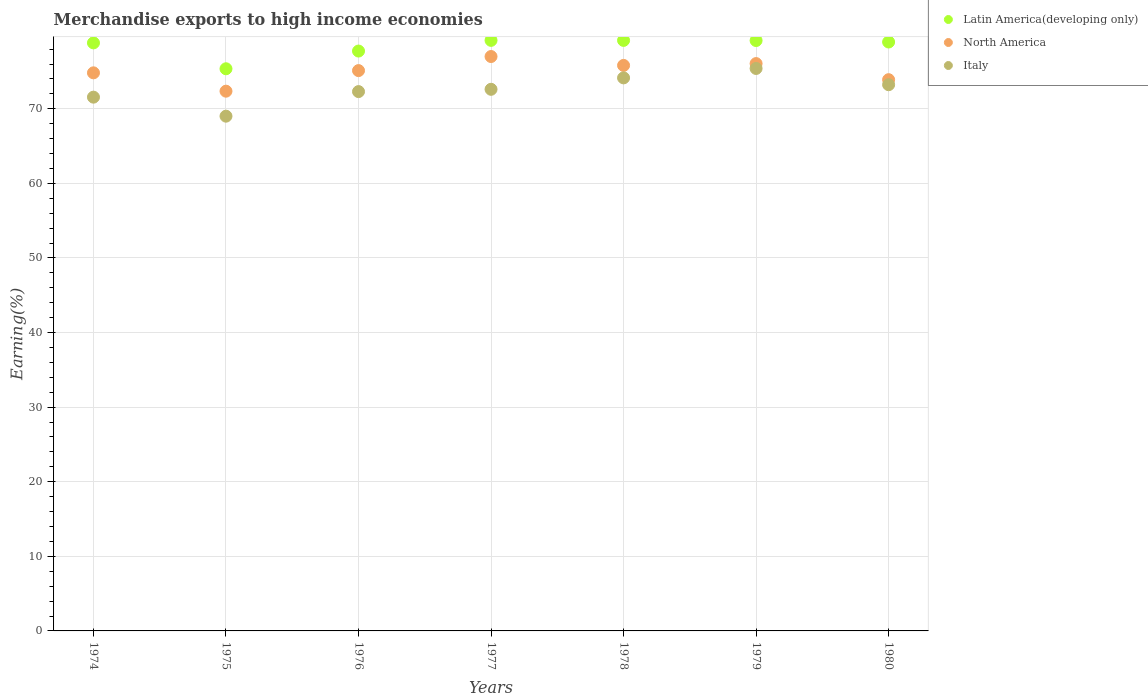Is the number of dotlines equal to the number of legend labels?
Your answer should be compact. Yes. What is the percentage of amount earned from merchandise exports in North America in 1975?
Provide a succinct answer. 72.36. Across all years, what is the maximum percentage of amount earned from merchandise exports in Latin America(developing only)?
Keep it short and to the point. 79.17. Across all years, what is the minimum percentage of amount earned from merchandise exports in Italy?
Make the answer very short. 69.01. In which year was the percentage of amount earned from merchandise exports in Italy maximum?
Keep it short and to the point. 1979. In which year was the percentage of amount earned from merchandise exports in Latin America(developing only) minimum?
Offer a terse response. 1975. What is the total percentage of amount earned from merchandise exports in North America in the graph?
Your answer should be compact. 525.07. What is the difference between the percentage of amount earned from merchandise exports in Italy in 1974 and that in 1975?
Your answer should be very brief. 2.55. What is the difference between the percentage of amount earned from merchandise exports in Latin America(developing only) in 1979 and the percentage of amount earned from merchandise exports in Italy in 1976?
Your response must be concise. 6.85. What is the average percentage of amount earned from merchandise exports in North America per year?
Provide a succinct answer. 75.01. In the year 1974, what is the difference between the percentage of amount earned from merchandise exports in North America and percentage of amount earned from merchandise exports in Latin America(developing only)?
Ensure brevity in your answer.  -4.02. What is the ratio of the percentage of amount earned from merchandise exports in Latin America(developing only) in 1979 to that in 1980?
Make the answer very short. 1. Is the percentage of amount earned from merchandise exports in Latin America(developing only) in 1974 less than that in 1979?
Your answer should be very brief. Yes. Is the difference between the percentage of amount earned from merchandise exports in North America in 1976 and 1978 greater than the difference between the percentage of amount earned from merchandise exports in Latin America(developing only) in 1976 and 1978?
Your answer should be compact. Yes. What is the difference between the highest and the second highest percentage of amount earned from merchandise exports in Latin America(developing only)?
Provide a succinct answer. 0. What is the difference between the highest and the lowest percentage of amount earned from merchandise exports in North America?
Your answer should be compact. 4.65. Does the percentage of amount earned from merchandise exports in Italy monotonically increase over the years?
Make the answer very short. No. Is the percentage of amount earned from merchandise exports in North America strictly greater than the percentage of amount earned from merchandise exports in Italy over the years?
Offer a very short reply. Yes. Does the graph contain any zero values?
Offer a terse response. No. Where does the legend appear in the graph?
Offer a terse response. Top right. How are the legend labels stacked?
Your answer should be very brief. Vertical. What is the title of the graph?
Your answer should be compact. Merchandise exports to high income economies. What is the label or title of the X-axis?
Your answer should be very brief. Years. What is the label or title of the Y-axis?
Provide a short and direct response. Earning(%). What is the Earning(%) of Latin America(developing only) in 1974?
Keep it short and to the point. 78.83. What is the Earning(%) in North America in 1974?
Offer a terse response. 74.82. What is the Earning(%) of Italy in 1974?
Keep it short and to the point. 71.56. What is the Earning(%) in Latin America(developing only) in 1975?
Offer a very short reply. 75.36. What is the Earning(%) in North America in 1975?
Keep it short and to the point. 72.36. What is the Earning(%) in Italy in 1975?
Offer a terse response. 69.01. What is the Earning(%) in Latin America(developing only) in 1976?
Keep it short and to the point. 77.74. What is the Earning(%) of North America in 1976?
Provide a succinct answer. 75.12. What is the Earning(%) of Italy in 1976?
Offer a terse response. 72.3. What is the Earning(%) of Latin America(developing only) in 1977?
Offer a very short reply. 79.17. What is the Earning(%) in North America in 1977?
Your response must be concise. 77. What is the Earning(%) of Italy in 1977?
Give a very brief answer. 72.61. What is the Earning(%) in Latin America(developing only) in 1978?
Your answer should be very brief. 79.17. What is the Earning(%) in North America in 1978?
Offer a very short reply. 75.81. What is the Earning(%) in Italy in 1978?
Provide a succinct answer. 74.14. What is the Earning(%) of Latin America(developing only) in 1979?
Your response must be concise. 79.15. What is the Earning(%) in North America in 1979?
Give a very brief answer. 76.06. What is the Earning(%) in Italy in 1979?
Make the answer very short. 75.4. What is the Earning(%) of Latin America(developing only) in 1980?
Your response must be concise. 78.95. What is the Earning(%) in North America in 1980?
Keep it short and to the point. 73.9. What is the Earning(%) in Italy in 1980?
Provide a short and direct response. 73.23. Across all years, what is the maximum Earning(%) of Latin America(developing only)?
Keep it short and to the point. 79.17. Across all years, what is the maximum Earning(%) of North America?
Your response must be concise. 77. Across all years, what is the maximum Earning(%) in Italy?
Offer a terse response. 75.4. Across all years, what is the minimum Earning(%) of Latin America(developing only)?
Provide a succinct answer. 75.36. Across all years, what is the minimum Earning(%) of North America?
Ensure brevity in your answer.  72.36. Across all years, what is the minimum Earning(%) of Italy?
Keep it short and to the point. 69.01. What is the total Earning(%) in Latin America(developing only) in the graph?
Give a very brief answer. 548.37. What is the total Earning(%) in North America in the graph?
Your response must be concise. 525.07. What is the total Earning(%) in Italy in the graph?
Keep it short and to the point. 508.25. What is the difference between the Earning(%) in Latin America(developing only) in 1974 and that in 1975?
Give a very brief answer. 3.47. What is the difference between the Earning(%) in North America in 1974 and that in 1975?
Give a very brief answer. 2.46. What is the difference between the Earning(%) in Italy in 1974 and that in 1975?
Your answer should be compact. 2.55. What is the difference between the Earning(%) of Latin America(developing only) in 1974 and that in 1976?
Offer a terse response. 1.09. What is the difference between the Earning(%) in North America in 1974 and that in 1976?
Your answer should be very brief. -0.3. What is the difference between the Earning(%) of Italy in 1974 and that in 1976?
Your answer should be compact. -0.75. What is the difference between the Earning(%) of Latin America(developing only) in 1974 and that in 1977?
Your response must be concise. -0.34. What is the difference between the Earning(%) of North America in 1974 and that in 1977?
Provide a short and direct response. -2.19. What is the difference between the Earning(%) in Italy in 1974 and that in 1977?
Your response must be concise. -1.05. What is the difference between the Earning(%) in Latin America(developing only) in 1974 and that in 1978?
Your answer should be compact. -0.33. What is the difference between the Earning(%) in North America in 1974 and that in 1978?
Provide a short and direct response. -1. What is the difference between the Earning(%) in Italy in 1974 and that in 1978?
Provide a short and direct response. -2.58. What is the difference between the Earning(%) of Latin America(developing only) in 1974 and that in 1979?
Provide a succinct answer. -0.32. What is the difference between the Earning(%) of North America in 1974 and that in 1979?
Your response must be concise. -1.24. What is the difference between the Earning(%) of Italy in 1974 and that in 1979?
Your response must be concise. -3.85. What is the difference between the Earning(%) of Latin America(developing only) in 1974 and that in 1980?
Offer a terse response. -0.12. What is the difference between the Earning(%) of North America in 1974 and that in 1980?
Your response must be concise. 0.92. What is the difference between the Earning(%) of Italy in 1974 and that in 1980?
Ensure brevity in your answer.  -1.67. What is the difference between the Earning(%) in Latin America(developing only) in 1975 and that in 1976?
Give a very brief answer. -2.37. What is the difference between the Earning(%) of North America in 1975 and that in 1976?
Your response must be concise. -2.76. What is the difference between the Earning(%) of Italy in 1975 and that in 1976?
Your answer should be very brief. -3.29. What is the difference between the Earning(%) in Latin America(developing only) in 1975 and that in 1977?
Offer a terse response. -3.81. What is the difference between the Earning(%) of North America in 1975 and that in 1977?
Give a very brief answer. -4.65. What is the difference between the Earning(%) in Italy in 1975 and that in 1977?
Ensure brevity in your answer.  -3.6. What is the difference between the Earning(%) of Latin America(developing only) in 1975 and that in 1978?
Keep it short and to the point. -3.8. What is the difference between the Earning(%) in North America in 1975 and that in 1978?
Give a very brief answer. -3.45. What is the difference between the Earning(%) of Italy in 1975 and that in 1978?
Keep it short and to the point. -5.13. What is the difference between the Earning(%) of Latin America(developing only) in 1975 and that in 1979?
Ensure brevity in your answer.  -3.79. What is the difference between the Earning(%) of North America in 1975 and that in 1979?
Provide a succinct answer. -3.7. What is the difference between the Earning(%) of Italy in 1975 and that in 1979?
Your answer should be compact. -6.4. What is the difference between the Earning(%) in Latin America(developing only) in 1975 and that in 1980?
Provide a short and direct response. -3.59. What is the difference between the Earning(%) in North America in 1975 and that in 1980?
Give a very brief answer. -1.54. What is the difference between the Earning(%) in Italy in 1975 and that in 1980?
Make the answer very short. -4.22. What is the difference between the Earning(%) in Latin America(developing only) in 1976 and that in 1977?
Your answer should be compact. -1.43. What is the difference between the Earning(%) in North America in 1976 and that in 1977?
Give a very brief answer. -1.89. What is the difference between the Earning(%) of Italy in 1976 and that in 1977?
Ensure brevity in your answer.  -0.31. What is the difference between the Earning(%) in Latin America(developing only) in 1976 and that in 1978?
Offer a very short reply. -1.43. What is the difference between the Earning(%) of North America in 1976 and that in 1978?
Keep it short and to the point. -0.69. What is the difference between the Earning(%) of Italy in 1976 and that in 1978?
Offer a very short reply. -1.84. What is the difference between the Earning(%) in Latin America(developing only) in 1976 and that in 1979?
Give a very brief answer. -1.41. What is the difference between the Earning(%) of North America in 1976 and that in 1979?
Keep it short and to the point. -0.94. What is the difference between the Earning(%) in Italy in 1976 and that in 1979?
Provide a succinct answer. -3.1. What is the difference between the Earning(%) in Latin America(developing only) in 1976 and that in 1980?
Ensure brevity in your answer.  -1.21. What is the difference between the Earning(%) of North America in 1976 and that in 1980?
Your answer should be very brief. 1.22. What is the difference between the Earning(%) in Italy in 1976 and that in 1980?
Offer a terse response. -0.92. What is the difference between the Earning(%) of Latin America(developing only) in 1977 and that in 1978?
Give a very brief answer. 0. What is the difference between the Earning(%) in North America in 1977 and that in 1978?
Your answer should be compact. 1.19. What is the difference between the Earning(%) of Italy in 1977 and that in 1978?
Your response must be concise. -1.53. What is the difference between the Earning(%) of Latin America(developing only) in 1977 and that in 1979?
Provide a succinct answer. 0.02. What is the difference between the Earning(%) in North America in 1977 and that in 1979?
Your answer should be very brief. 0.95. What is the difference between the Earning(%) in Italy in 1977 and that in 1979?
Your answer should be very brief. -2.79. What is the difference between the Earning(%) in Latin America(developing only) in 1977 and that in 1980?
Keep it short and to the point. 0.22. What is the difference between the Earning(%) of North America in 1977 and that in 1980?
Offer a terse response. 3.1. What is the difference between the Earning(%) in Italy in 1977 and that in 1980?
Make the answer very short. -0.62. What is the difference between the Earning(%) in Latin America(developing only) in 1978 and that in 1979?
Offer a terse response. 0.02. What is the difference between the Earning(%) of North America in 1978 and that in 1979?
Your answer should be compact. -0.25. What is the difference between the Earning(%) in Italy in 1978 and that in 1979?
Give a very brief answer. -1.26. What is the difference between the Earning(%) in Latin America(developing only) in 1978 and that in 1980?
Offer a terse response. 0.22. What is the difference between the Earning(%) of North America in 1978 and that in 1980?
Provide a succinct answer. 1.91. What is the difference between the Earning(%) of Italy in 1978 and that in 1980?
Your answer should be compact. 0.92. What is the difference between the Earning(%) of Latin America(developing only) in 1979 and that in 1980?
Your answer should be very brief. 0.2. What is the difference between the Earning(%) in North America in 1979 and that in 1980?
Your answer should be compact. 2.16. What is the difference between the Earning(%) in Italy in 1979 and that in 1980?
Your answer should be very brief. 2.18. What is the difference between the Earning(%) in Latin America(developing only) in 1974 and the Earning(%) in North America in 1975?
Give a very brief answer. 6.47. What is the difference between the Earning(%) of Latin America(developing only) in 1974 and the Earning(%) of Italy in 1975?
Offer a very short reply. 9.82. What is the difference between the Earning(%) of North America in 1974 and the Earning(%) of Italy in 1975?
Make the answer very short. 5.81. What is the difference between the Earning(%) of Latin America(developing only) in 1974 and the Earning(%) of North America in 1976?
Provide a short and direct response. 3.71. What is the difference between the Earning(%) of Latin America(developing only) in 1974 and the Earning(%) of Italy in 1976?
Provide a short and direct response. 6.53. What is the difference between the Earning(%) in North America in 1974 and the Earning(%) in Italy in 1976?
Give a very brief answer. 2.51. What is the difference between the Earning(%) in Latin America(developing only) in 1974 and the Earning(%) in North America in 1977?
Your answer should be very brief. 1.83. What is the difference between the Earning(%) in Latin America(developing only) in 1974 and the Earning(%) in Italy in 1977?
Make the answer very short. 6.22. What is the difference between the Earning(%) of North America in 1974 and the Earning(%) of Italy in 1977?
Your answer should be compact. 2.21. What is the difference between the Earning(%) in Latin America(developing only) in 1974 and the Earning(%) in North America in 1978?
Your answer should be very brief. 3.02. What is the difference between the Earning(%) of Latin America(developing only) in 1974 and the Earning(%) of Italy in 1978?
Your answer should be compact. 4.69. What is the difference between the Earning(%) of North America in 1974 and the Earning(%) of Italy in 1978?
Offer a terse response. 0.68. What is the difference between the Earning(%) of Latin America(developing only) in 1974 and the Earning(%) of North America in 1979?
Your answer should be compact. 2.77. What is the difference between the Earning(%) in Latin America(developing only) in 1974 and the Earning(%) in Italy in 1979?
Provide a succinct answer. 3.43. What is the difference between the Earning(%) of North America in 1974 and the Earning(%) of Italy in 1979?
Provide a succinct answer. -0.59. What is the difference between the Earning(%) of Latin America(developing only) in 1974 and the Earning(%) of North America in 1980?
Offer a very short reply. 4.93. What is the difference between the Earning(%) of Latin America(developing only) in 1974 and the Earning(%) of Italy in 1980?
Ensure brevity in your answer.  5.61. What is the difference between the Earning(%) of North America in 1974 and the Earning(%) of Italy in 1980?
Your response must be concise. 1.59. What is the difference between the Earning(%) in Latin America(developing only) in 1975 and the Earning(%) in North America in 1976?
Your answer should be very brief. 0.25. What is the difference between the Earning(%) of Latin America(developing only) in 1975 and the Earning(%) of Italy in 1976?
Give a very brief answer. 3.06. What is the difference between the Earning(%) of North America in 1975 and the Earning(%) of Italy in 1976?
Provide a short and direct response. 0.06. What is the difference between the Earning(%) in Latin America(developing only) in 1975 and the Earning(%) in North America in 1977?
Ensure brevity in your answer.  -1.64. What is the difference between the Earning(%) in Latin America(developing only) in 1975 and the Earning(%) in Italy in 1977?
Offer a very short reply. 2.75. What is the difference between the Earning(%) in North America in 1975 and the Earning(%) in Italy in 1977?
Your answer should be very brief. -0.25. What is the difference between the Earning(%) of Latin America(developing only) in 1975 and the Earning(%) of North America in 1978?
Offer a very short reply. -0.45. What is the difference between the Earning(%) of Latin America(developing only) in 1975 and the Earning(%) of Italy in 1978?
Keep it short and to the point. 1.22. What is the difference between the Earning(%) in North America in 1975 and the Earning(%) in Italy in 1978?
Ensure brevity in your answer.  -1.78. What is the difference between the Earning(%) of Latin America(developing only) in 1975 and the Earning(%) of North America in 1979?
Ensure brevity in your answer.  -0.7. What is the difference between the Earning(%) in Latin America(developing only) in 1975 and the Earning(%) in Italy in 1979?
Give a very brief answer. -0.04. What is the difference between the Earning(%) in North America in 1975 and the Earning(%) in Italy in 1979?
Give a very brief answer. -3.05. What is the difference between the Earning(%) of Latin America(developing only) in 1975 and the Earning(%) of North America in 1980?
Keep it short and to the point. 1.46. What is the difference between the Earning(%) in Latin America(developing only) in 1975 and the Earning(%) in Italy in 1980?
Your response must be concise. 2.14. What is the difference between the Earning(%) of North America in 1975 and the Earning(%) of Italy in 1980?
Give a very brief answer. -0.87. What is the difference between the Earning(%) in Latin America(developing only) in 1976 and the Earning(%) in North America in 1977?
Make the answer very short. 0.73. What is the difference between the Earning(%) in Latin America(developing only) in 1976 and the Earning(%) in Italy in 1977?
Provide a succinct answer. 5.13. What is the difference between the Earning(%) of North America in 1976 and the Earning(%) of Italy in 1977?
Offer a terse response. 2.51. What is the difference between the Earning(%) in Latin America(developing only) in 1976 and the Earning(%) in North America in 1978?
Make the answer very short. 1.93. What is the difference between the Earning(%) of Latin America(developing only) in 1976 and the Earning(%) of Italy in 1978?
Your answer should be compact. 3.6. What is the difference between the Earning(%) in North America in 1976 and the Earning(%) in Italy in 1978?
Keep it short and to the point. 0.98. What is the difference between the Earning(%) in Latin America(developing only) in 1976 and the Earning(%) in North America in 1979?
Give a very brief answer. 1.68. What is the difference between the Earning(%) in Latin America(developing only) in 1976 and the Earning(%) in Italy in 1979?
Keep it short and to the point. 2.33. What is the difference between the Earning(%) of North America in 1976 and the Earning(%) of Italy in 1979?
Provide a succinct answer. -0.29. What is the difference between the Earning(%) in Latin America(developing only) in 1976 and the Earning(%) in North America in 1980?
Offer a very short reply. 3.84. What is the difference between the Earning(%) of Latin America(developing only) in 1976 and the Earning(%) of Italy in 1980?
Your answer should be compact. 4.51. What is the difference between the Earning(%) of North America in 1976 and the Earning(%) of Italy in 1980?
Offer a terse response. 1.89. What is the difference between the Earning(%) in Latin America(developing only) in 1977 and the Earning(%) in North America in 1978?
Provide a succinct answer. 3.36. What is the difference between the Earning(%) in Latin America(developing only) in 1977 and the Earning(%) in Italy in 1978?
Your answer should be very brief. 5.03. What is the difference between the Earning(%) of North America in 1977 and the Earning(%) of Italy in 1978?
Keep it short and to the point. 2.86. What is the difference between the Earning(%) of Latin America(developing only) in 1977 and the Earning(%) of North America in 1979?
Your answer should be very brief. 3.11. What is the difference between the Earning(%) in Latin America(developing only) in 1977 and the Earning(%) in Italy in 1979?
Provide a succinct answer. 3.77. What is the difference between the Earning(%) of North America in 1977 and the Earning(%) of Italy in 1979?
Provide a succinct answer. 1.6. What is the difference between the Earning(%) of Latin America(developing only) in 1977 and the Earning(%) of North America in 1980?
Offer a terse response. 5.27. What is the difference between the Earning(%) in Latin America(developing only) in 1977 and the Earning(%) in Italy in 1980?
Make the answer very short. 5.95. What is the difference between the Earning(%) in North America in 1977 and the Earning(%) in Italy in 1980?
Offer a very short reply. 3.78. What is the difference between the Earning(%) of Latin America(developing only) in 1978 and the Earning(%) of North America in 1979?
Keep it short and to the point. 3.11. What is the difference between the Earning(%) of Latin America(developing only) in 1978 and the Earning(%) of Italy in 1979?
Your answer should be compact. 3.76. What is the difference between the Earning(%) in North America in 1978 and the Earning(%) in Italy in 1979?
Give a very brief answer. 0.41. What is the difference between the Earning(%) in Latin America(developing only) in 1978 and the Earning(%) in North America in 1980?
Offer a very short reply. 5.27. What is the difference between the Earning(%) of Latin America(developing only) in 1978 and the Earning(%) of Italy in 1980?
Your response must be concise. 5.94. What is the difference between the Earning(%) in North America in 1978 and the Earning(%) in Italy in 1980?
Make the answer very short. 2.59. What is the difference between the Earning(%) of Latin America(developing only) in 1979 and the Earning(%) of North America in 1980?
Provide a succinct answer. 5.25. What is the difference between the Earning(%) of Latin America(developing only) in 1979 and the Earning(%) of Italy in 1980?
Offer a terse response. 5.92. What is the difference between the Earning(%) of North America in 1979 and the Earning(%) of Italy in 1980?
Your answer should be very brief. 2.83. What is the average Earning(%) in Latin America(developing only) per year?
Keep it short and to the point. 78.34. What is the average Earning(%) of North America per year?
Offer a very short reply. 75.01. What is the average Earning(%) of Italy per year?
Your response must be concise. 72.61. In the year 1974, what is the difference between the Earning(%) of Latin America(developing only) and Earning(%) of North America?
Give a very brief answer. 4.01. In the year 1974, what is the difference between the Earning(%) of Latin America(developing only) and Earning(%) of Italy?
Keep it short and to the point. 7.28. In the year 1974, what is the difference between the Earning(%) in North America and Earning(%) in Italy?
Offer a terse response. 3.26. In the year 1975, what is the difference between the Earning(%) in Latin America(developing only) and Earning(%) in North America?
Offer a terse response. 3.01. In the year 1975, what is the difference between the Earning(%) in Latin America(developing only) and Earning(%) in Italy?
Ensure brevity in your answer.  6.36. In the year 1975, what is the difference between the Earning(%) in North America and Earning(%) in Italy?
Your answer should be compact. 3.35. In the year 1976, what is the difference between the Earning(%) of Latin America(developing only) and Earning(%) of North America?
Make the answer very short. 2.62. In the year 1976, what is the difference between the Earning(%) of Latin America(developing only) and Earning(%) of Italy?
Your answer should be very brief. 5.43. In the year 1976, what is the difference between the Earning(%) in North America and Earning(%) in Italy?
Keep it short and to the point. 2.82. In the year 1977, what is the difference between the Earning(%) of Latin America(developing only) and Earning(%) of North America?
Ensure brevity in your answer.  2.17. In the year 1977, what is the difference between the Earning(%) of Latin America(developing only) and Earning(%) of Italy?
Provide a succinct answer. 6.56. In the year 1977, what is the difference between the Earning(%) of North America and Earning(%) of Italy?
Your response must be concise. 4.39. In the year 1978, what is the difference between the Earning(%) of Latin America(developing only) and Earning(%) of North America?
Offer a very short reply. 3.35. In the year 1978, what is the difference between the Earning(%) of Latin America(developing only) and Earning(%) of Italy?
Give a very brief answer. 5.03. In the year 1978, what is the difference between the Earning(%) in North America and Earning(%) in Italy?
Keep it short and to the point. 1.67. In the year 1979, what is the difference between the Earning(%) in Latin America(developing only) and Earning(%) in North America?
Make the answer very short. 3.09. In the year 1979, what is the difference between the Earning(%) of Latin America(developing only) and Earning(%) of Italy?
Give a very brief answer. 3.74. In the year 1979, what is the difference between the Earning(%) of North America and Earning(%) of Italy?
Your answer should be very brief. 0.65. In the year 1980, what is the difference between the Earning(%) of Latin America(developing only) and Earning(%) of North America?
Your response must be concise. 5.05. In the year 1980, what is the difference between the Earning(%) of Latin America(developing only) and Earning(%) of Italy?
Keep it short and to the point. 5.72. In the year 1980, what is the difference between the Earning(%) of North America and Earning(%) of Italy?
Offer a terse response. 0.68. What is the ratio of the Earning(%) in Latin America(developing only) in 1974 to that in 1975?
Keep it short and to the point. 1.05. What is the ratio of the Earning(%) of North America in 1974 to that in 1975?
Provide a short and direct response. 1.03. What is the ratio of the Earning(%) in Italy in 1974 to that in 1975?
Your response must be concise. 1.04. What is the ratio of the Earning(%) in Latin America(developing only) in 1974 to that in 1976?
Provide a short and direct response. 1.01. What is the ratio of the Earning(%) of North America in 1974 to that in 1977?
Make the answer very short. 0.97. What is the ratio of the Earning(%) of Italy in 1974 to that in 1977?
Offer a very short reply. 0.99. What is the ratio of the Earning(%) in North America in 1974 to that in 1978?
Your response must be concise. 0.99. What is the ratio of the Earning(%) in Italy in 1974 to that in 1978?
Provide a short and direct response. 0.97. What is the ratio of the Earning(%) in North America in 1974 to that in 1979?
Give a very brief answer. 0.98. What is the ratio of the Earning(%) of Italy in 1974 to that in 1979?
Your answer should be compact. 0.95. What is the ratio of the Earning(%) in Latin America(developing only) in 1974 to that in 1980?
Your answer should be compact. 1. What is the ratio of the Earning(%) in North America in 1974 to that in 1980?
Give a very brief answer. 1.01. What is the ratio of the Earning(%) in Italy in 1974 to that in 1980?
Your answer should be very brief. 0.98. What is the ratio of the Earning(%) of Latin America(developing only) in 1975 to that in 1976?
Your answer should be very brief. 0.97. What is the ratio of the Earning(%) in North America in 1975 to that in 1976?
Your response must be concise. 0.96. What is the ratio of the Earning(%) in Italy in 1975 to that in 1976?
Make the answer very short. 0.95. What is the ratio of the Earning(%) of Latin America(developing only) in 1975 to that in 1977?
Your response must be concise. 0.95. What is the ratio of the Earning(%) of North America in 1975 to that in 1977?
Offer a terse response. 0.94. What is the ratio of the Earning(%) in Italy in 1975 to that in 1977?
Your response must be concise. 0.95. What is the ratio of the Earning(%) in Latin America(developing only) in 1975 to that in 1978?
Give a very brief answer. 0.95. What is the ratio of the Earning(%) of North America in 1975 to that in 1978?
Offer a terse response. 0.95. What is the ratio of the Earning(%) of Italy in 1975 to that in 1978?
Provide a short and direct response. 0.93. What is the ratio of the Earning(%) of Latin America(developing only) in 1975 to that in 1979?
Offer a very short reply. 0.95. What is the ratio of the Earning(%) in North America in 1975 to that in 1979?
Provide a succinct answer. 0.95. What is the ratio of the Earning(%) of Italy in 1975 to that in 1979?
Ensure brevity in your answer.  0.92. What is the ratio of the Earning(%) in Latin America(developing only) in 1975 to that in 1980?
Give a very brief answer. 0.95. What is the ratio of the Earning(%) in North America in 1975 to that in 1980?
Provide a short and direct response. 0.98. What is the ratio of the Earning(%) of Italy in 1975 to that in 1980?
Ensure brevity in your answer.  0.94. What is the ratio of the Earning(%) of Latin America(developing only) in 1976 to that in 1977?
Your answer should be very brief. 0.98. What is the ratio of the Earning(%) in North America in 1976 to that in 1977?
Give a very brief answer. 0.98. What is the ratio of the Earning(%) of Latin America(developing only) in 1976 to that in 1978?
Ensure brevity in your answer.  0.98. What is the ratio of the Earning(%) of Italy in 1976 to that in 1978?
Make the answer very short. 0.98. What is the ratio of the Earning(%) of Latin America(developing only) in 1976 to that in 1979?
Keep it short and to the point. 0.98. What is the ratio of the Earning(%) of North America in 1976 to that in 1979?
Your response must be concise. 0.99. What is the ratio of the Earning(%) of Italy in 1976 to that in 1979?
Give a very brief answer. 0.96. What is the ratio of the Earning(%) in Latin America(developing only) in 1976 to that in 1980?
Provide a succinct answer. 0.98. What is the ratio of the Earning(%) of North America in 1976 to that in 1980?
Your response must be concise. 1.02. What is the ratio of the Earning(%) of Italy in 1976 to that in 1980?
Provide a succinct answer. 0.99. What is the ratio of the Earning(%) in Latin America(developing only) in 1977 to that in 1978?
Your answer should be compact. 1. What is the ratio of the Earning(%) of North America in 1977 to that in 1978?
Ensure brevity in your answer.  1.02. What is the ratio of the Earning(%) in Italy in 1977 to that in 1978?
Your answer should be compact. 0.98. What is the ratio of the Earning(%) of Latin America(developing only) in 1977 to that in 1979?
Keep it short and to the point. 1. What is the ratio of the Earning(%) of North America in 1977 to that in 1979?
Ensure brevity in your answer.  1.01. What is the ratio of the Earning(%) of Italy in 1977 to that in 1979?
Give a very brief answer. 0.96. What is the ratio of the Earning(%) in Latin America(developing only) in 1977 to that in 1980?
Keep it short and to the point. 1. What is the ratio of the Earning(%) of North America in 1977 to that in 1980?
Give a very brief answer. 1.04. What is the ratio of the Earning(%) of Italy in 1977 to that in 1980?
Provide a succinct answer. 0.99. What is the ratio of the Earning(%) of Italy in 1978 to that in 1979?
Offer a terse response. 0.98. What is the ratio of the Earning(%) of Latin America(developing only) in 1978 to that in 1980?
Make the answer very short. 1. What is the ratio of the Earning(%) of North America in 1978 to that in 1980?
Make the answer very short. 1.03. What is the ratio of the Earning(%) in Italy in 1978 to that in 1980?
Make the answer very short. 1.01. What is the ratio of the Earning(%) in Latin America(developing only) in 1979 to that in 1980?
Your answer should be compact. 1. What is the ratio of the Earning(%) of North America in 1979 to that in 1980?
Your answer should be compact. 1.03. What is the ratio of the Earning(%) in Italy in 1979 to that in 1980?
Provide a short and direct response. 1.03. What is the difference between the highest and the second highest Earning(%) of Latin America(developing only)?
Provide a succinct answer. 0. What is the difference between the highest and the second highest Earning(%) of North America?
Ensure brevity in your answer.  0.95. What is the difference between the highest and the second highest Earning(%) of Italy?
Offer a terse response. 1.26. What is the difference between the highest and the lowest Earning(%) of Latin America(developing only)?
Make the answer very short. 3.81. What is the difference between the highest and the lowest Earning(%) in North America?
Provide a succinct answer. 4.65. What is the difference between the highest and the lowest Earning(%) in Italy?
Provide a short and direct response. 6.4. 